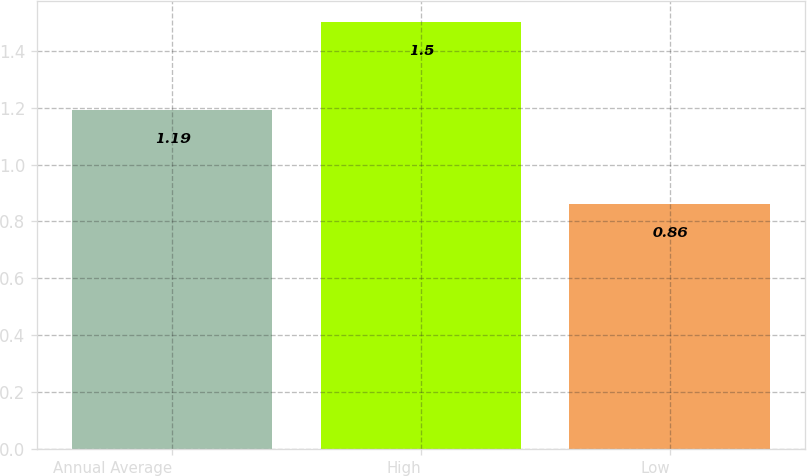<chart> <loc_0><loc_0><loc_500><loc_500><bar_chart><fcel>Annual Average<fcel>High<fcel>Low<nl><fcel>1.19<fcel>1.5<fcel>0.86<nl></chart> 